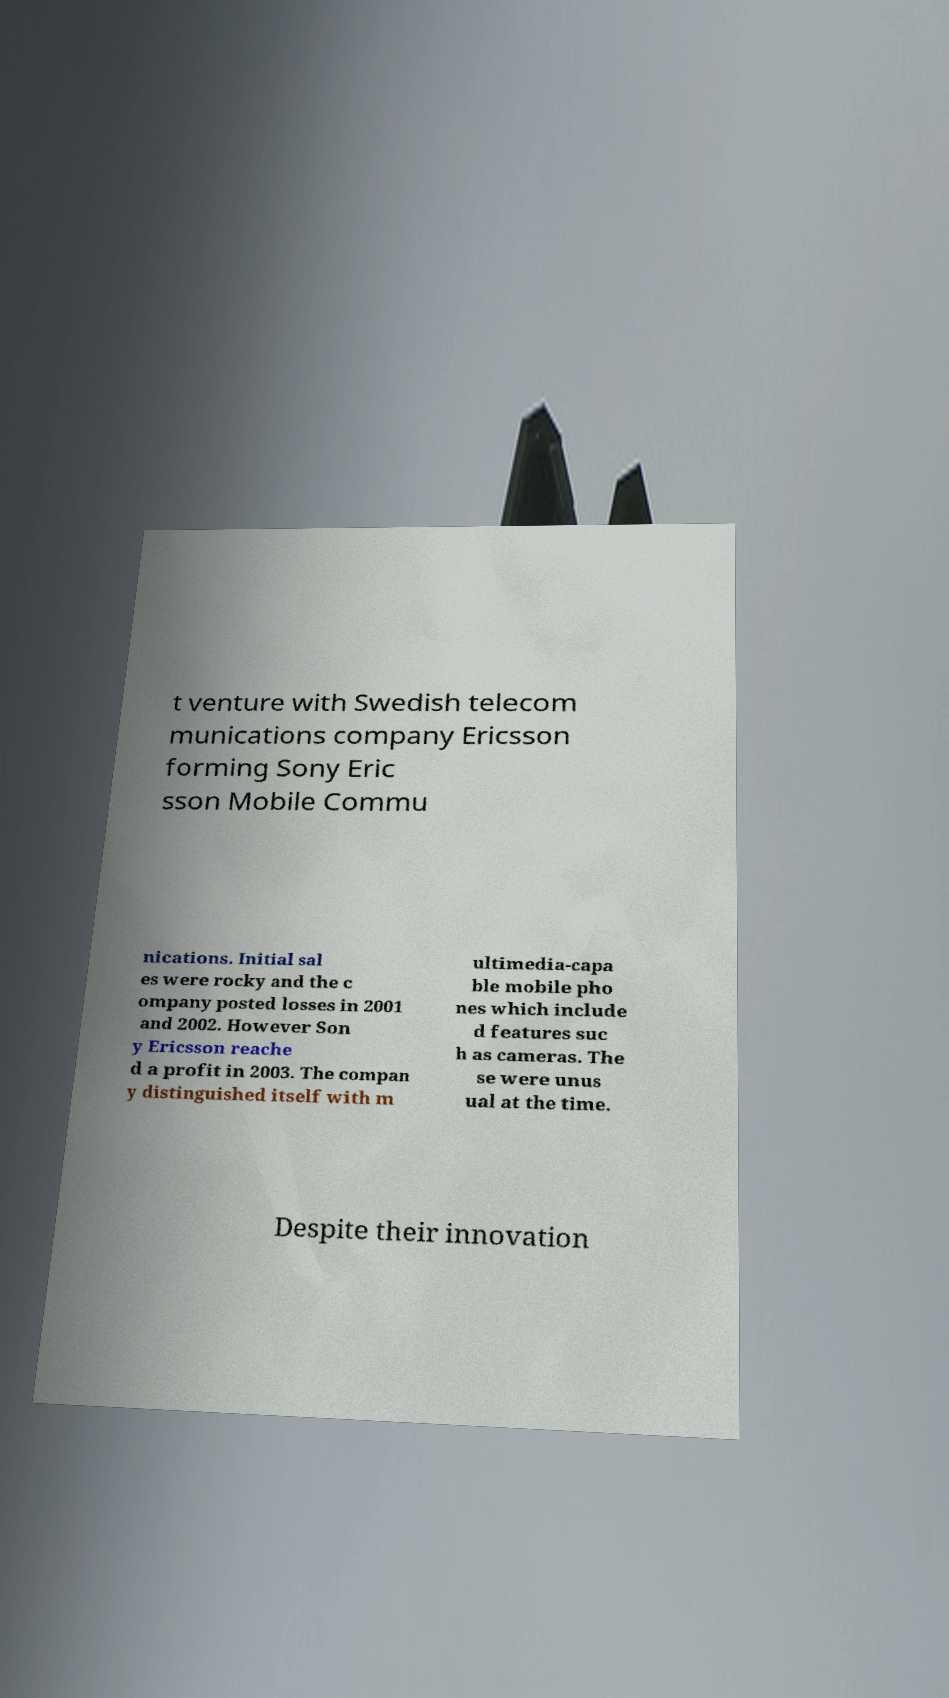Could you extract and type out the text from this image? t venture with Swedish telecom munications company Ericsson forming Sony Eric sson Mobile Commu nications. Initial sal es were rocky and the c ompany posted losses in 2001 and 2002. However Son y Ericsson reache d a profit in 2003. The compan y distinguished itself with m ultimedia-capa ble mobile pho nes which include d features suc h as cameras. The se were unus ual at the time. Despite their innovation 